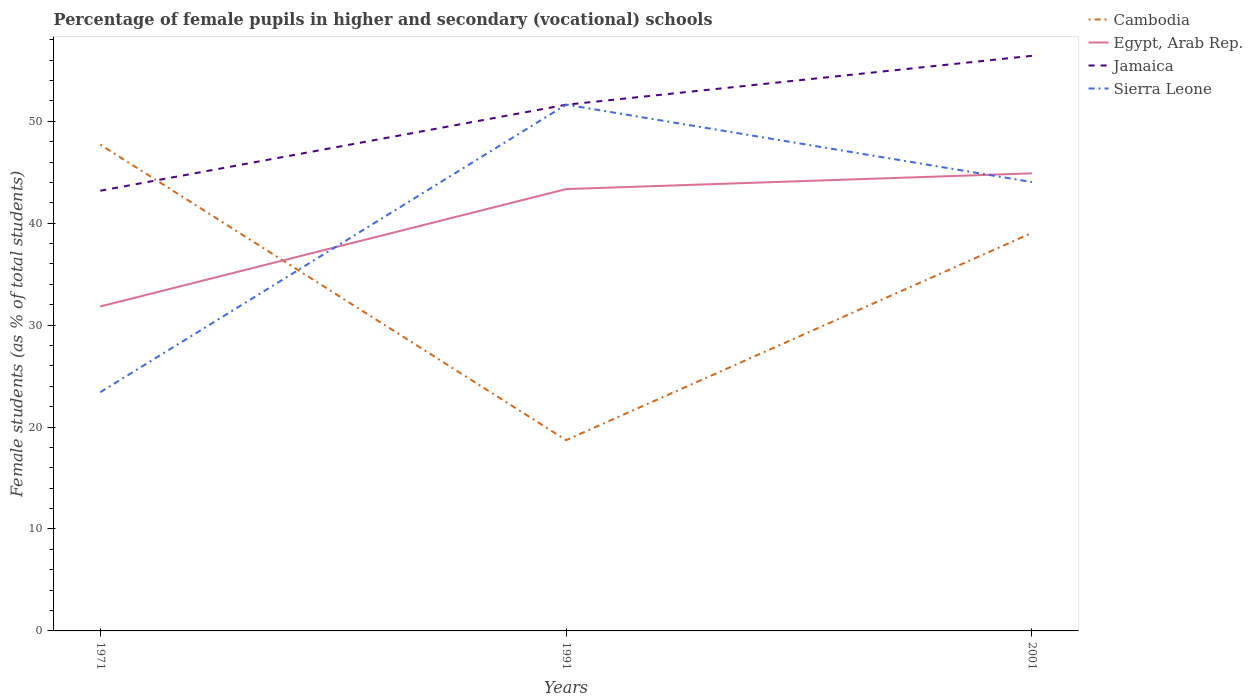How many different coloured lines are there?
Keep it short and to the point. 4. Is the number of lines equal to the number of legend labels?
Your answer should be compact. Yes. Across all years, what is the maximum percentage of female pupils in higher and secondary schools in Egypt, Arab Rep.?
Offer a very short reply. 31.83. In which year was the percentage of female pupils in higher and secondary schools in Egypt, Arab Rep. maximum?
Your response must be concise. 1971. What is the total percentage of female pupils in higher and secondary schools in Jamaica in the graph?
Offer a terse response. -4.8. What is the difference between the highest and the second highest percentage of female pupils in higher and secondary schools in Sierra Leone?
Make the answer very short. 28.21. What is the difference between the highest and the lowest percentage of female pupils in higher and secondary schools in Jamaica?
Your answer should be compact. 2. Is the percentage of female pupils in higher and secondary schools in Egypt, Arab Rep. strictly greater than the percentage of female pupils in higher and secondary schools in Sierra Leone over the years?
Offer a terse response. No. What is the difference between two consecutive major ticks on the Y-axis?
Offer a terse response. 10. Does the graph contain any zero values?
Your answer should be compact. No. Where does the legend appear in the graph?
Your answer should be very brief. Top right. How are the legend labels stacked?
Provide a short and direct response. Vertical. What is the title of the graph?
Your answer should be compact. Percentage of female pupils in higher and secondary (vocational) schools. What is the label or title of the Y-axis?
Your answer should be compact. Female students (as % of total students). What is the Female students (as % of total students) of Cambodia in 1971?
Provide a succinct answer. 47.71. What is the Female students (as % of total students) in Egypt, Arab Rep. in 1971?
Ensure brevity in your answer.  31.83. What is the Female students (as % of total students) in Jamaica in 1971?
Your answer should be compact. 43.19. What is the Female students (as % of total students) in Sierra Leone in 1971?
Your response must be concise. 23.42. What is the Female students (as % of total students) of Cambodia in 1991?
Ensure brevity in your answer.  18.72. What is the Female students (as % of total students) of Egypt, Arab Rep. in 1991?
Your answer should be very brief. 43.35. What is the Female students (as % of total students) in Jamaica in 1991?
Provide a short and direct response. 51.63. What is the Female students (as % of total students) of Sierra Leone in 1991?
Give a very brief answer. 51.63. What is the Female students (as % of total students) of Cambodia in 2001?
Your answer should be very brief. 39.05. What is the Female students (as % of total students) of Egypt, Arab Rep. in 2001?
Give a very brief answer. 44.89. What is the Female students (as % of total students) of Jamaica in 2001?
Provide a short and direct response. 56.43. What is the Female students (as % of total students) in Sierra Leone in 2001?
Provide a short and direct response. 44.04. Across all years, what is the maximum Female students (as % of total students) in Cambodia?
Ensure brevity in your answer.  47.71. Across all years, what is the maximum Female students (as % of total students) of Egypt, Arab Rep.?
Give a very brief answer. 44.89. Across all years, what is the maximum Female students (as % of total students) in Jamaica?
Give a very brief answer. 56.43. Across all years, what is the maximum Female students (as % of total students) of Sierra Leone?
Keep it short and to the point. 51.63. Across all years, what is the minimum Female students (as % of total students) in Cambodia?
Give a very brief answer. 18.72. Across all years, what is the minimum Female students (as % of total students) of Egypt, Arab Rep.?
Provide a succinct answer. 31.83. Across all years, what is the minimum Female students (as % of total students) of Jamaica?
Provide a succinct answer. 43.19. Across all years, what is the minimum Female students (as % of total students) in Sierra Leone?
Ensure brevity in your answer.  23.42. What is the total Female students (as % of total students) of Cambodia in the graph?
Keep it short and to the point. 105.48. What is the total Female students (as % of total students) in Egypt, Arab Rep. in the graph?
Offer a terse response. 120.07. What is the total Female students (as % of total students) in Jamaica in the graph?
Offer a terse response. 151.24. What is the total Female students (as % of total students) of Sierra Leone in the graph?
Make the answer very short. 119.09. What is the difference between the Female students (as % of total students) of Cambodia in 1971 and that in 1991?
Offer a terse response. 28.99. What is the difference between the Female students (as % of total students) of Egypt, Arab Rep. in 1971 and that in 1991?
Your answer should be compact. -11.52. What is the difference between the Female students (as % of total students) in Jamaica in 1971 and that in 1991?
Your answer should be very brief. -8.44. What is the difference between the Female students (as % of total students) of Sierra Leone in 1971 and that in 1991?
Make the answer very short. -28.21. What is the difference between the Female students (as % of total students) in Cambodia in 1971 and that in 2001?
Your answer should be compact. 8.66. What is the difference between the Female students (as % of total students) in Egypt, Arab Rep. in 1971 and that in 2001?
Ensure brevity in your answer.  -13.06. What is the difference between the Female students (as % of total students) in Jamaica in 1971 and that in 2001?
Make the answer very short. -13.24. What is the difference between the Female students (as % of total students) in Sierra Leone in 1971 and that in 2001?
Offer a very short reply. -20.62. What is the difference between the Female students (as % of total students) in Cambodia in 1991 and that in 2001?
Keep it short and to the point. -20.34. What is the difference between the Female students (as % of total students) in Egypt, Arab Rep. in 1991 and that in 2001?
Give a very brief answer. -1.54. What is the difference between the Female students (as % of total students) in Sierra Leone in 1991 and that in 2001?
Ensure brevity in your answer.  7.59. What is the difference between the Female students (as % of total students) in Cambodia in 1971 and the Female students (as % of total students) in Egypt, Arab Rep. in 1991?
Your answer should be compact. 4.36. What is the difference between the Female students (as % of total students) in Cambodia in 1971 and the Female students (as % of total students) in Jamaica in 1991?
Give a very brief answer. -3.92. What is the difference between the Female students (as % of total students) of Cambodia in 1971 and the Female students (as % of total students) of Sierra Leone in 1991?
Ensure brevity in your answer.  -3.92. What is the difference between the Female students (as % of total students) in Egypt, Arab Rep. in 1971 and the Female students (as % of total students) in Jamaica in 1991?
Make the answer very short. -19.79. What is the difference between the Female students (as % of total students) in Egypt, Arab Rep. in 1971 and the Female students (as % of total students) in Sierra Leone in 1991?
Offer a very short reply. -19.8. What is the difference between the Female students (as % of total students) of Jamaica in 1971 and the Female students (as % of total students) of Sierra Leone in 1991?
Keep it short and to the point. -8.44. What is the difference between the Female students (as % of total students) of Cambodia in 1971 and the Female students (as % of total students) of Egypt, Arab Rep. in 2001?
Offer a terse response. 2.82. What is the difference between the Female students (as % of total students) in Cambodia in 1971 and the Female students (as % of total students) in Jamaica in 2001?
Provide a short and direct response. -8.72. What is the difference between the Female students (as % of total students) of Cambodia in 1971 and the Female students (as % of total students) of Sierra Leone in 2001?
Your response must be concise. 3.67. What is the difference between the Female students (as % of total students) of Egypt, Arab Rep. in 1971 and the Female students (as % of total students) of Jamaica in 2001?
Your answer should be very brief. -24.59. What is the difference between the Female students (as % of total students) of Egypt, Arab Rep. in 1971 and the Female students (as % of total students) of Sierra Leone in 2001?
Provide a short and direct response. -12.21. What is the difference between the Female students (as % of total students) of Jamaica in 1971 and the Female students (as % of total students) of Sierra Leone in 2001?
Your response must be concise. -0.85. What is the difference between the Female students (as % of total students) in Cambodia in 1991 and the Female students (as % of total students) in Egypt, Arab Rep. in 2001?
Offer a very short reply. -26.18. What is the difference between the Female students (as % of total students) of Cambodia in 1991 and the Female students (as % of total students) of Jamaica in 2001?
Your answer should be compact. -37.71. What is the difference between the Female students (as % of total students) in Cambodia in 1991 and the Female students (as % of total students) in Sierra Leone in 2001?
Ensure brevity in your answer.  -25.32. What is the difference between the Female students (as % of total students) of Egypt, Arab Rep. in 1991 and the Female students (as % of total students) of Jamaica in 2001?
Provide a succinct answer. -13.08. What is the difference between the Female students (as % of total students) of Egypt, Arab Rep. in 1991 and the Female students (as % of total students) of Sierra Leone in 2001?
Offer a very short reply. -0.69. What is the difference between the Female students (as % of total students) of Jamaica in 1991 and the Female students (as % of total students) of Sierra Leone in 2001?
Your answer should be compact. 7.59. What is the average Female students (as % of total students) of Cambodia per year?
Offer a terse response. 35.16. What is the average Female students (as % of total students) of Egypt, Arab Rep. per year?
Keep it short and to the point. 40.02. What is the average Female students (as % of total students) in Jamaica per year?
Provide a succinct answer. 50.41. What is the average Female students (as % of total students) in Sierra Leone per year?
Keep it short and to the point. 39.7. In the year 1971, what is the difference between the Female students (as % of total students) in Cambodia and Female students (as % of total students) in Egypt, Arab Rep.?
Your response must be concise. 15.88. In the year 1971, what is the difference between the Female students (as % of total students) of Cambodia and Female students (as % of total students) of Jamaica?
Keep it short and to the point. 4.52. In the year 1971, what is the difference between the Female students (as % of total students) of Cambodia and Female students (as % of total students) of Sierra Leone?
Your answer should be very brief. 24.29. In the year 1971, what is the difference between the Female students (as % of total students) of Egypt, Arab Rep. and Female students (as % of total students) of Jamaica?
Keep it short and to the point. -11.36. In the year 1971, what is the difference between the Female students (as % of total students) in Egypt, Arab Rep. and Female students (as % of total students) in Sierra Leone?
Make the answer very short. 8.41. In the year 1971, what is the difference between the Female students (as % of total students) in Jamaica and Female students (as % of total students) in Sierra Leone?
Your response must be concise. 19.77. In the year 1991, what is the difference between the Female students (as % of total students) in Cambodia and Female students (as % of total students) in Egypt, Arab Rep.?
Your answer should be compact. -24.63. In the year 1991, what is the difference between the Female students (as % of total students) in Cambodia and Female students (as % of total students) in Jamaica?
Make the answer very short. -32.91. In the year 1991, what is the difference between the Female students (as % of total students) in Cambodia and Female students (as % of total students) in Sierra Leone?
Keep it short and to the point. -32.91. In the year 1991, what is the difference between the Female students (as % of total students) in Egypt, Arab Rep. and Female students (as % of total students) in Jamaica?
Offer a very short reply. -8.28. In the year 1991, what is the difference between the Female students (as % of total students) of Egypt, Arab Rep. and Female students (as % of total students) of Sierra Leone?
Your answer should be very brief. -8.28. In the year 1991, what is the difference between the Female students (as % of total students) in Jamaica and Female students (as % of total students) in Sierra Leone?
Give a very brief answer. -0.01. In the year 2001, what is the difference between the Female students (as % of total students) in Cambodia and Female students (as % of total students) in Egypt, Arab Rep.?
Your answer should be compact. -5.84. In the year 2001, what is the difference between the Female students (as % of total students) in Cambodia and Female students (as % of total students) in Jamaica?
Provide a short and direct response. -17.37. In the year 2001, what is the difference between the Female students (as % of total students) in Cambodia and Female students (as % of total students) in Sierra Leone?
Offer a very short reply. -4.99. In the year 2001, what is the difference between the Female students (as % of total students) in Egypt, Arab Rep. and Female students (as % of total students) in Jamaica?
Your response must be concise. -11.53. In the year 2001, what is the difference between the Female students (as % of total students) of Egypt, Arab Rep. and Female students (as % of total students) of Sierra Leone?
Offer a terse response. 0.85. In the year 2001, what is the difference between the Female students (as % of total students) in Jamaica and Female students (as % of total students) in Sierra Leone?
Your answer should be very brief. 12.39. What is the ratio of the Female students (as % of total students) of Cambodia in 1971 to that in 1991?
Your answer should be compact. 2.55. What is the ratio of the Female students (as % of total students) of Egypt, Arab Rep. in 1971 to that in 1991?
Give a very brief answer. 0.73. What is the ratio of the Female students (as % of total students) of Jamaica in 1971 to that in 1991?
Offer a very short reply. 0.84. What is the ratio of the Female students (as % of total students) in Sierra Leone in 1971 to that in 1991?
Offer a very short reply. 0.45. What is the ratio of the Female students (as % of total students) in Cambodia in 1971 to that in 2001?
Offer a very short reply. 1.22. What is the ratio of the Female students (as % of total students) of Egypt, Arab Rep. in 1971 to that in 2001?
Your answer should be very brief. 0.71. What is the ratio of the Female students (as % of total students) of Jamaica in 1971 to that in 2001?
Provide a succinct answer. 0.77. What is the ratio of the Female students (as % of total students) in Sierra Leone in 1971 to that in 2001?
Your response must be concise. 0.53. What is the ratio of the Female students (as % of total students) in Cambodia in 1991 to that in 2001?
Ensure brevity in your answer.  0.48. What is the ratio of the Female students (as % of total students) of Egypt, Arab Rep. in 1991 to that in 2001?
Give a very brief answer. 0.97. What is the ratio of the Female students (as % of total students) in Jamaica in 1991 to that in 2001?
Give a very brief answer. 0.91. What is the ratio of the Female students (as % of total students) of Sierra Leone in 1991 to that in 2001?
Your answer should be very brief. 1.17. What is the difference between the highest and the second highest Female students (as % of total students) in Cambodia?
Your response must be concise. 8.66. What is the difference between the highest and the second highest Female students (as % of total students) of Egypt, Arab Rep.?
Provide a short and direct response. 1.54. What is the difference between the highest and the second highest Female students (as % of total students) of Jamaica?
Give a very brief answer. 4.8. What is the difference between the highest and the second highest Female students (as % of total students) in Sierra Leone?
Your answer should be very brief. 7.59. What is the difference between the highest and the lowest Female students (as % of total students) in Cambodia?
Keep it short and to the point. 28.99. What is the difference between the highest and the lowest Female students (as % of total students) in Egypt, Arab Rep.?
Provide a short and direct response. 13.06. What is the difference between the highest and the lowest Female students (as % of total students) of Jamaica?
Offer a terse response. 13.24. What is the difference between the highest and the lowest Female students (as % of total students) of Sierra Leone?
Ensure brevity in your answer.  28.21. 